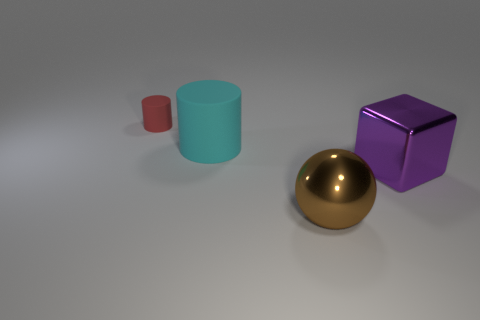Does the red thing have the same shape as the large purple object? no 